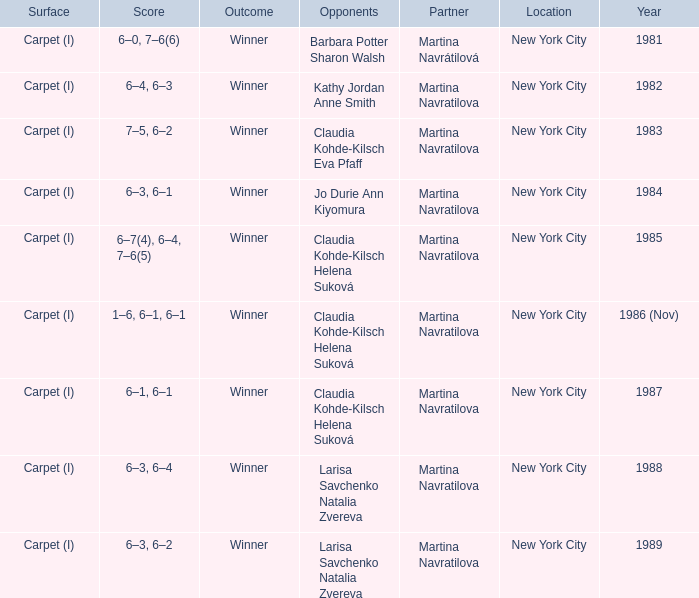How many partners were there in 1988? 1.0. Help me parse the entirety of this table. {'header': ['Surface', 'Score', 'Outcome', 'Opponents', 'Partner', 'Location', 'Year'], 'rows': [['Carpet (I)', '6–0, 7–6(6)', 'Winner', 'Barbara Potter Sharon Walsh', 'Martina Navrátilová', 'New York City', '1981'], ['Carpet (I)', '6–4, 6–3', 'Winner', 'Kathy Jordan Anne Smith', 'Martina Navratilova', 'New York City', '1982'], ['Carpet (I)', '7–5, 6–2', 'Winner', 'Claudia Kohde-Kilsch Eva Pfaff', 'Martina Navratilova', 'New York City', '1983'], ['Carpet (I)', '6–3, 6–1', 'Winner', 'Jo Durie Ann Kiyomura', 'Martina Navratilova', 'New York City', '1984'], ['Carpet (I)', '6–7(4), 6–4, 7–6(5)', 'Winner', 'Claudia Kohde-Kilsch Helena Suková', 'Martina Navratilova', 'New York City', '1985'], ['Carpet (I)', '1–6, 6–1, 6–1', 'Winner', 'Claudia Kohde-Kilsch Helena Suková', 'Martina Navratilova', 'New York City', '1986 (Nov)'], ['Carpet (I)', '6–1, 6–1', 'Winner', 'Claudia Kohde-Kilsch Helena Suková', 'Martina Navratilova', 'New York City', '1987'], ['Carpet (I)', '6–3, 6–4', 'Winner', 'Larisa Savchenko Natalia Zvereva', 'Martina Navratilova', 'New York City', '1988'], ['Carpet (I)', '6–3, 6–2', 'Winner', 'Larisa Savchenko Natalia Zvereva', 'Martina Navratilova', 'New York City', '1989']]} 